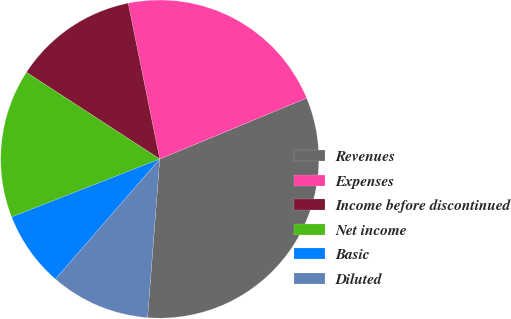<chart> <loc_0><loc_0><loc_500><loc_500><pie_chart><fcel>Revenues<fcel>Expenses<fcel>Income before discontinued<fcel>Net income<fcel>Basic<fcel>Diluted<nl><fcel>32.48%<fcel>21.92%<fcel>12.64%<fcel>15.12%<fcel>7.68%<fcel>10.16%<nl></chart> 